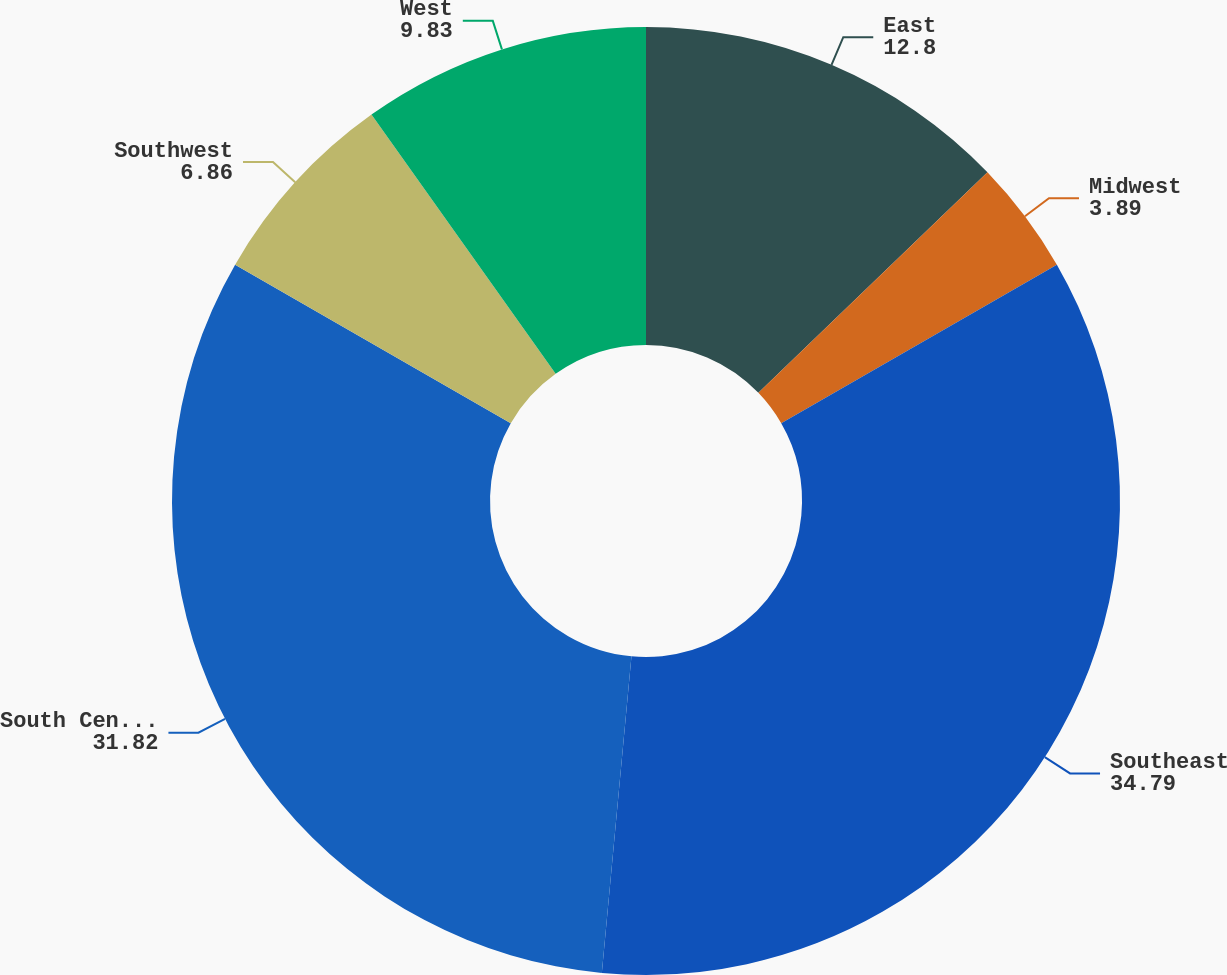<chart> <loc_0><loc_0><loc_500><loc_500><pie_chart><fcel>East<fcel>Midwest<fcel>Southeast<fcel>South Central<fcel>Southwest<fcel>West<nl><fcel>12.8%<fcel>3.89%<fcel>34.79%<fcel>31.82%<fcel>6.86%<fcel>9.83%<nl></chart> 